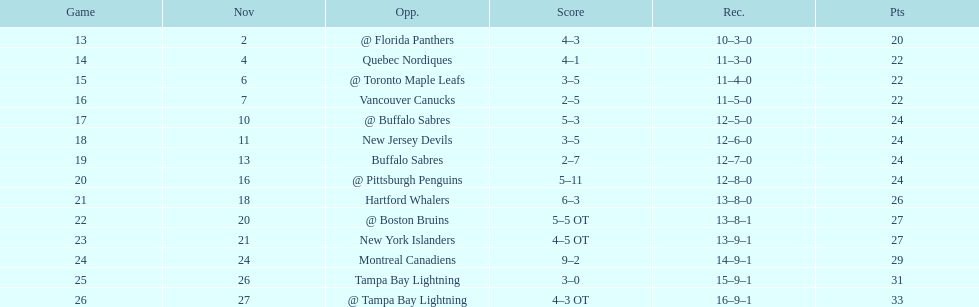Did the tampa bay lightning have the least amount of wins? Yes. 